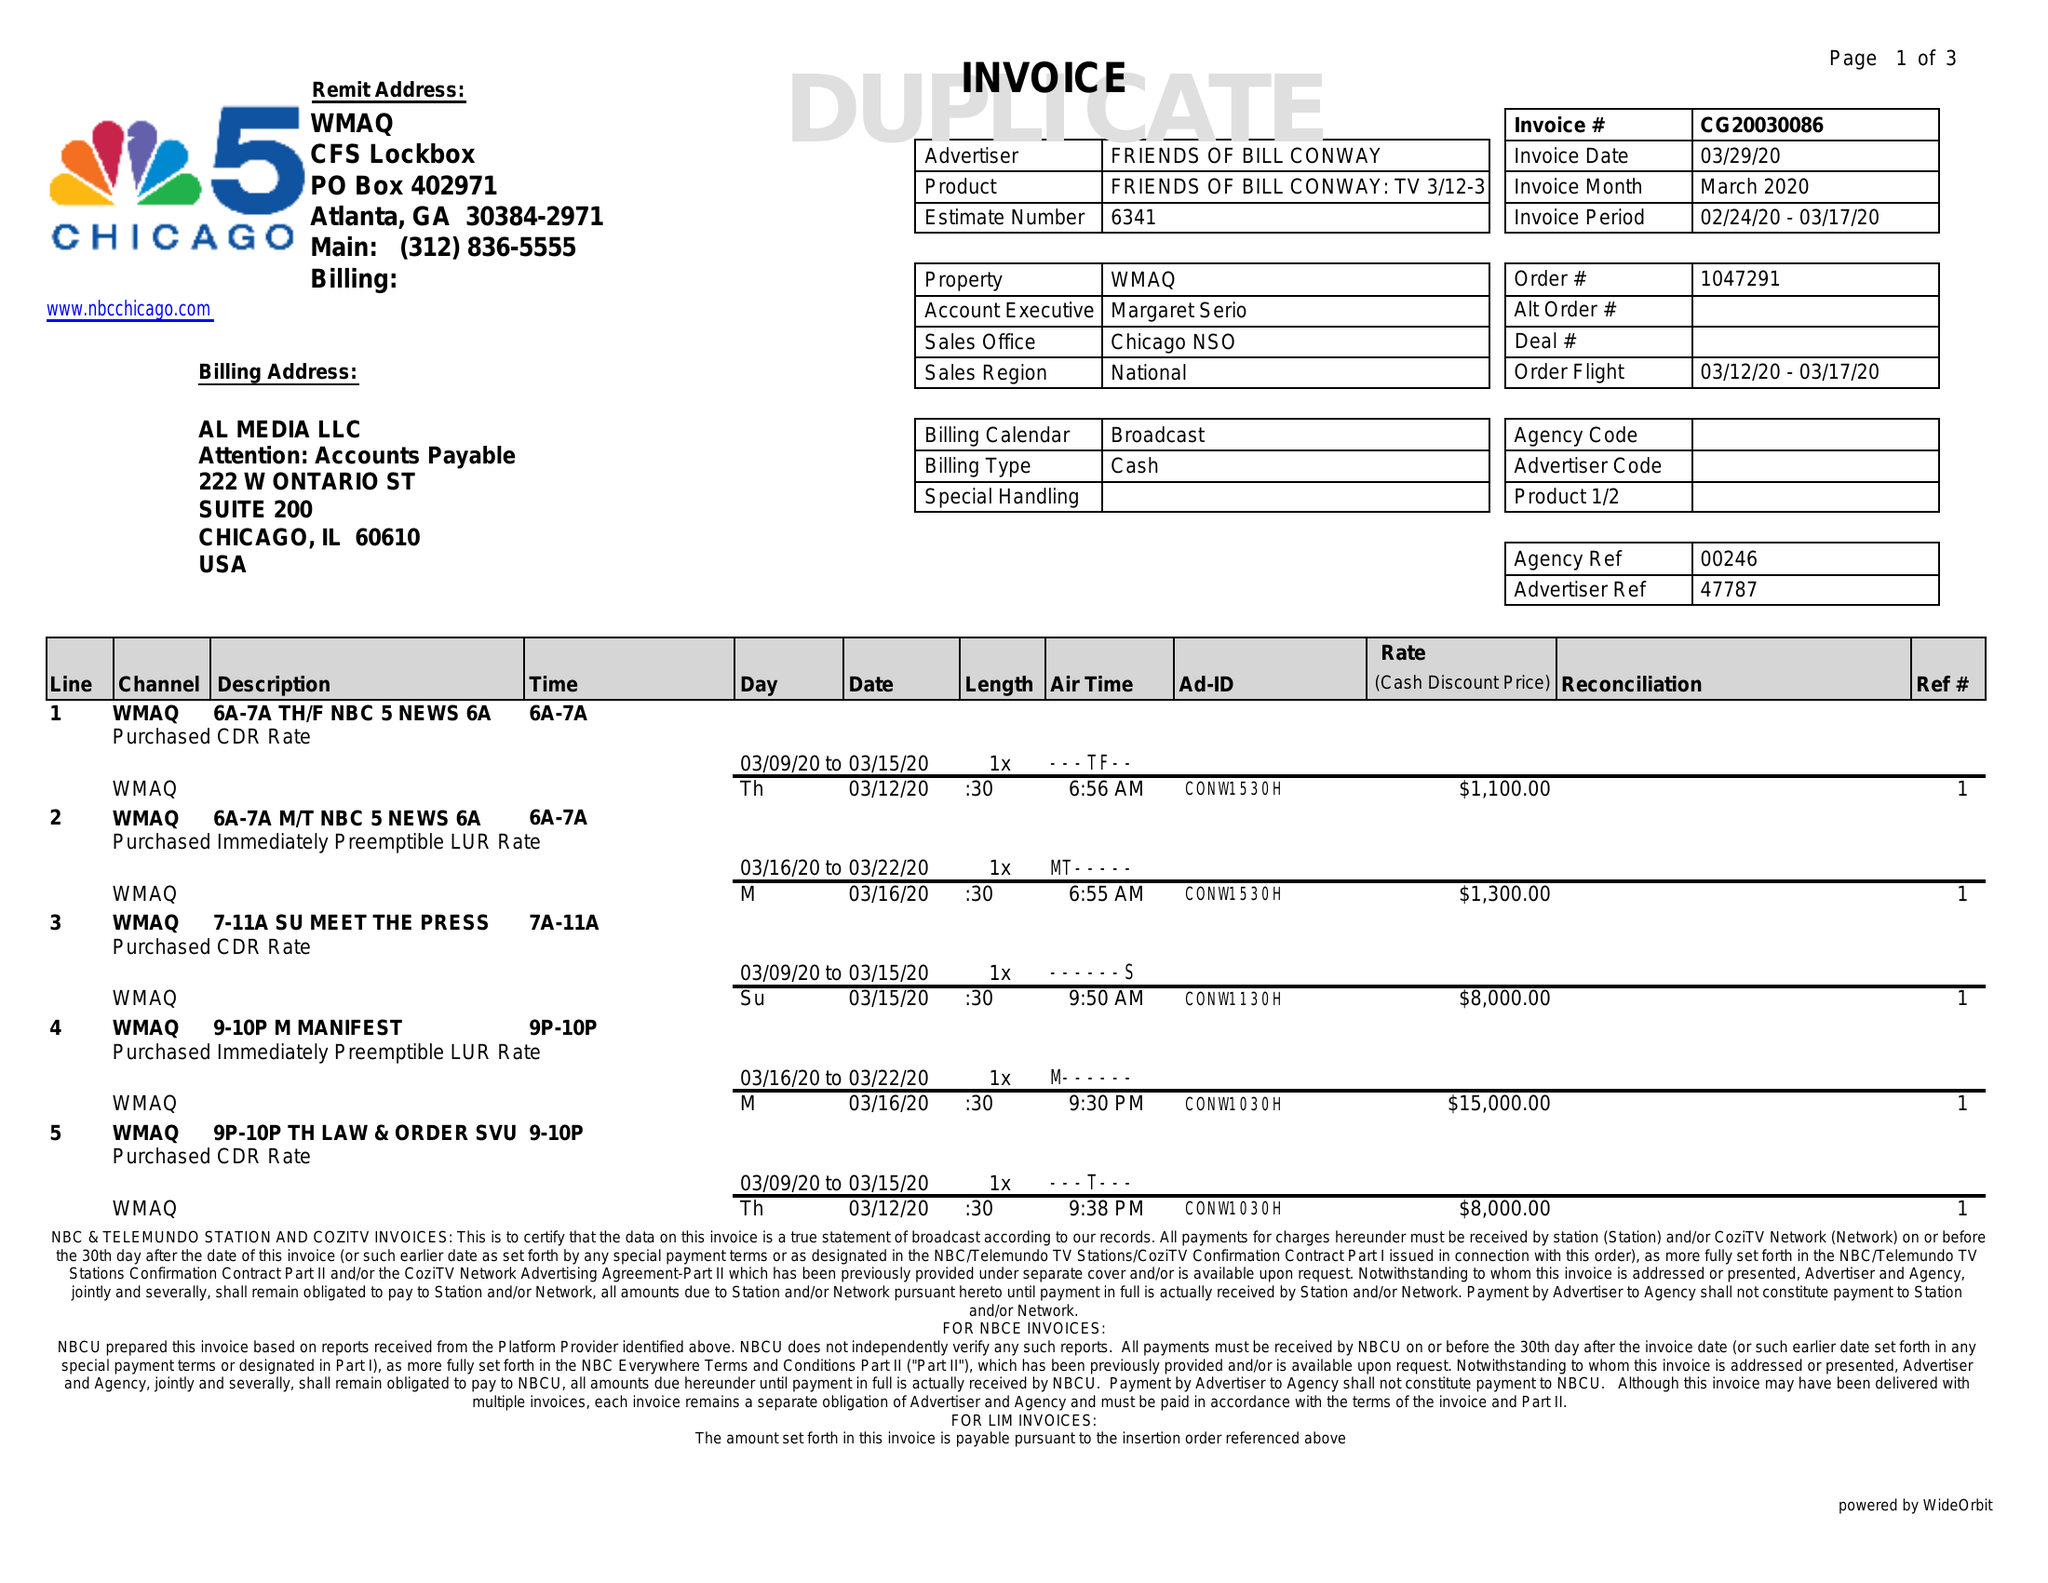What is the value for the flight_from?
Answer the question using a single word or phrase. 03/12/20 